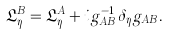<formula> <loc_0><loc_0><loc_500><loc_500>\mathfrak { L } _ { \eta } ^ { B } = \mathfrak { L } _ { \eta } ^ { A } + i g _ { A B } ^ { - 1 } \delta _ { \eta } g _ { A B } .</formula> 